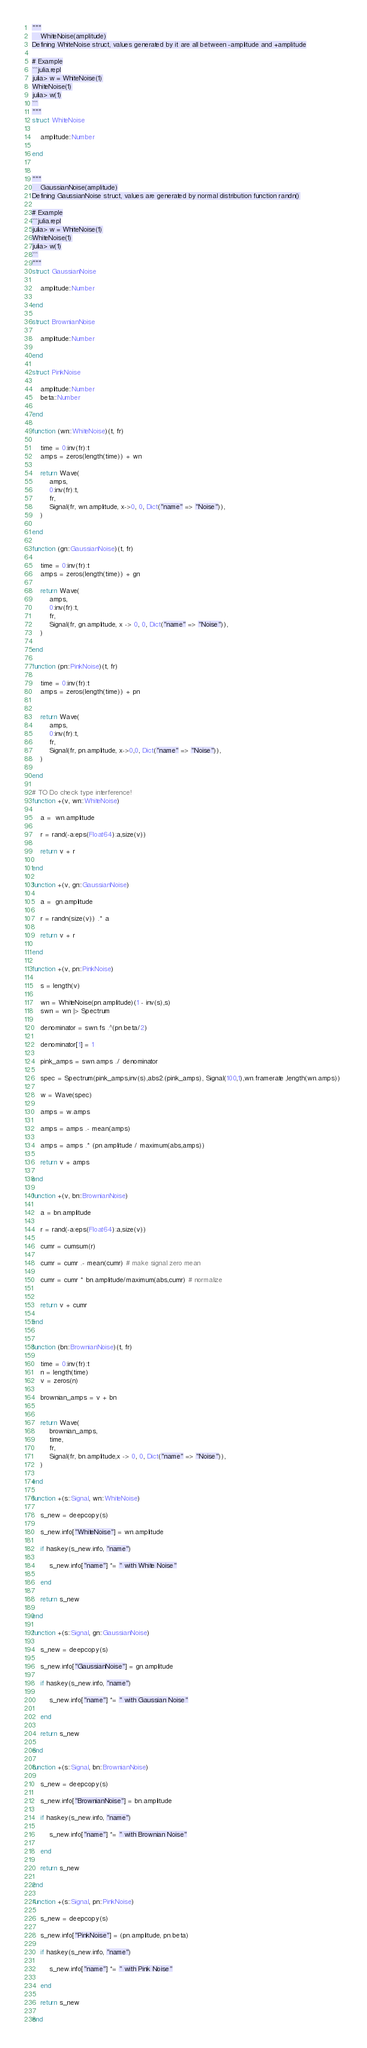<code> <loc_0><loc_0><loc_500><loc_500><_Julia_>"""
    WhiteNoise(amplitude)
Defining WhiteNoise struct, values generated by it are all between -amplitude and +amplitude

# Example
```julia.repl
julia> w = WhiteNoise(1)
WhiteNoise(1)
julia> w(1)
```
"""
struct WhiteNoise

    amplitude::Number

end


"""
    GaussianNoise(amplitude)
Defining GaussianNoise struct, values are generated by normal distribution function randn()

# Example
```julia.repl
julia> w = WhiteNoise(1)
WhiteNoise(1)
julia> w(1)
```
"""
struct GaussianNoise

    amplitude::Number

end

struct BrownianNoise

    amplitude::Number

end

struct PinkNoise

    amplitude::Number
    beta::Number

end

function (wn::WhiteNoise)(t, fr)

    time = 0:inv(fr):t
    amps = zeros(length(time)) + wn

    return Wave(
        amps,
        0:inv(fr):t,
        fr,
        Signal(fr, wn.amplitude, x->0, 0, Dict("name" => "Noise")),
    )

end

function (gn::GaussianNoise)(t, fr)

    time = 0:inv(fr):t
    amps = zeros(length(time)) + gn

    return Wave(
        amps,
        0:inv(fr):t,
        fr,
        Signal(fr, gn.amplitude, x -> 0, 0, Dict("name" => "Noise")),
    )

end

function (pn::PinkNoise)(t, fr)

    time = 0:inv(fr):t
    amps = zeros(length(time)) + pn


    return Wave(
        amps,
        0:inv(fr):t,
        fr,
        Signal(fr, pn.amplitude, x->0,0, Dict("name" => "Noise")),
    )

end

# TO Do check type interference!
function +(v, wn::WhiteNoise)

    a =  wn.amplitude

    r = rand(-a:eps(Float64):a,size(v)) 

    return v + r

end

function +(v, gn::GaussianNoise)

    a =  gn.amplitude

    r = randn(size(v)) .* a

    return v + r

end

function +(v, pn::PinkNoise)

    s = length(v)

    wn = WhiteNoise(pn.amplitude)(1 - inv(s),s) 
    swn = wn |> Spectrum

    denominator = swn.fs .^(pn.beta/2)

    denominator[1] = 1
    
    pink_amps = swn.amps ./ denominator

    spec = Spectrum(pink_amps,inv(s),abs2.(pink_amps), Signal(100,1),wn.framerate ,length(wn.amps)) 

    w = Wave(spec)

    amps = w.amps

    amps = amps .- mean(amps)

    amps = amps .* (pn.amplitude / maximum(abs,amps))

    return v + amps

end

function +(v, bn::BrownianNoise)

    a = bn.amplitude

    r = rand(-a:eps(Float64):a,size(v)) 

    cumr = cumsum(r) 

    cumr = cumr .- mean(cumr) # make signal zero mean

    cumr = cumr * bn.amplitude/maximum(abs,cumr) # normalize
    

    return v + cumr

end


function (bn::BrownianNoise)(t, fr)

    time = 0:inv(fr):t
    n = length(time)
    v = zeros(n)
    
    brownian_amps = v + bn


    return Wave(
        brownian_amps,
        time,
        fr,
        Signal(fr, bn.amplitude,x -> 0, 0, Dict("name" => "Noise")),
    )

end

function +(s::Signal, wn::WhiteNoise)

    s_new = deepcopy(s)

    s_new.info["WhiteNoise"] = wn.amplitude

    if haskey(s_new.info, "name")

        s_new.info["name"] *= " with White Noise"

    end

    return s_new

end

function +(s::Signal, gn::GaussianNoise)

    s_new = deepcopy(s)

    s_new.info["GaussianNoise"] = gn.amplitude

    if haskey(s_new.info, "name")

        s_new.info["name"] *= " with Gaussian Noise"

    end

    return s_new

end

function +(s::Signal, bn::BrownianNoise)

    s_new = deepcopy(s)

    s_new.info["BrownianNoise"] = bn.amplitude

    if haskey(s_new.info, "name")

        s_new.info["name"] *= " with Brownian Noise"

    end

    return s_new

end

function +(s::Signal, pn::PinkNoise)

    s_new = deepcopy(s)

    s_new.info["PinkNoise"] = (pn.amplitude, pn.beta)

    if haskey(s_new.info, "name")

        s_new.info["name"] *= " with Pink Noise"

    end

    return s_new

end</code> 